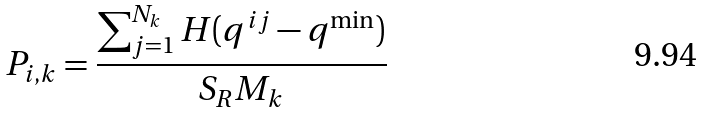<formula> <loc_0><loc_0><loc_500><loc_500>P _ { i , k } = \frac { \sum _ { j = 1 } ^ { N _ { k } } H ( q ^ { i j } - q ^ { \min } ) } { S _ { R } M _ { k } }</formula> 